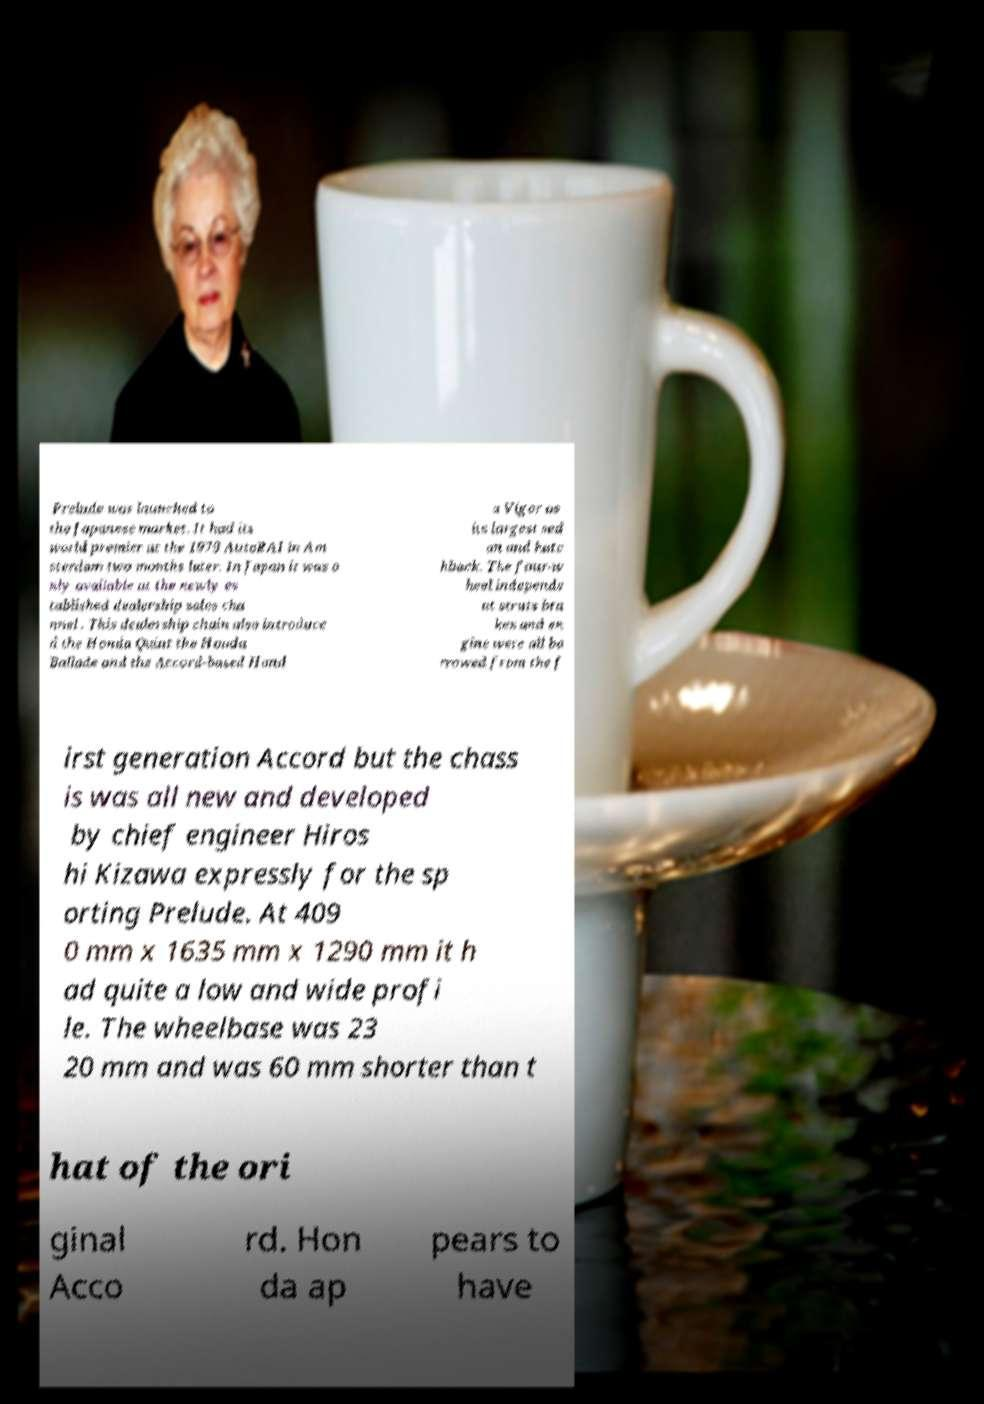Could you assist in decoding the text presented in this image and type it out clearly? Prelude was launched to the Japanese market. It had its world premier at the 1979 AutoRAI in Am sterdam two months later. In Japan it was o nly available at the newly es tablished dealership sales cha nnel . This dealership chain also introduce d the Honda Quint the Honda Ballade and the Accord-based Hond a Vigor as its largest sed an and hatc hback. The four-w heel independe nt struts bra kes and en gine were all bo rrowed from the f irst generation Accord but the chass is was all new and developed by chief engineer Hiros hi Kizawa expressly for the sp orting Prelude. At 409 0 mm x 1635 mm x 1290 mm it h ad quite a low and wide profi le. The wheelbase was 23 20 mm and was 60 mm shorter than t hat of the ori ginal Acco rd. Hon da ap pears to have 